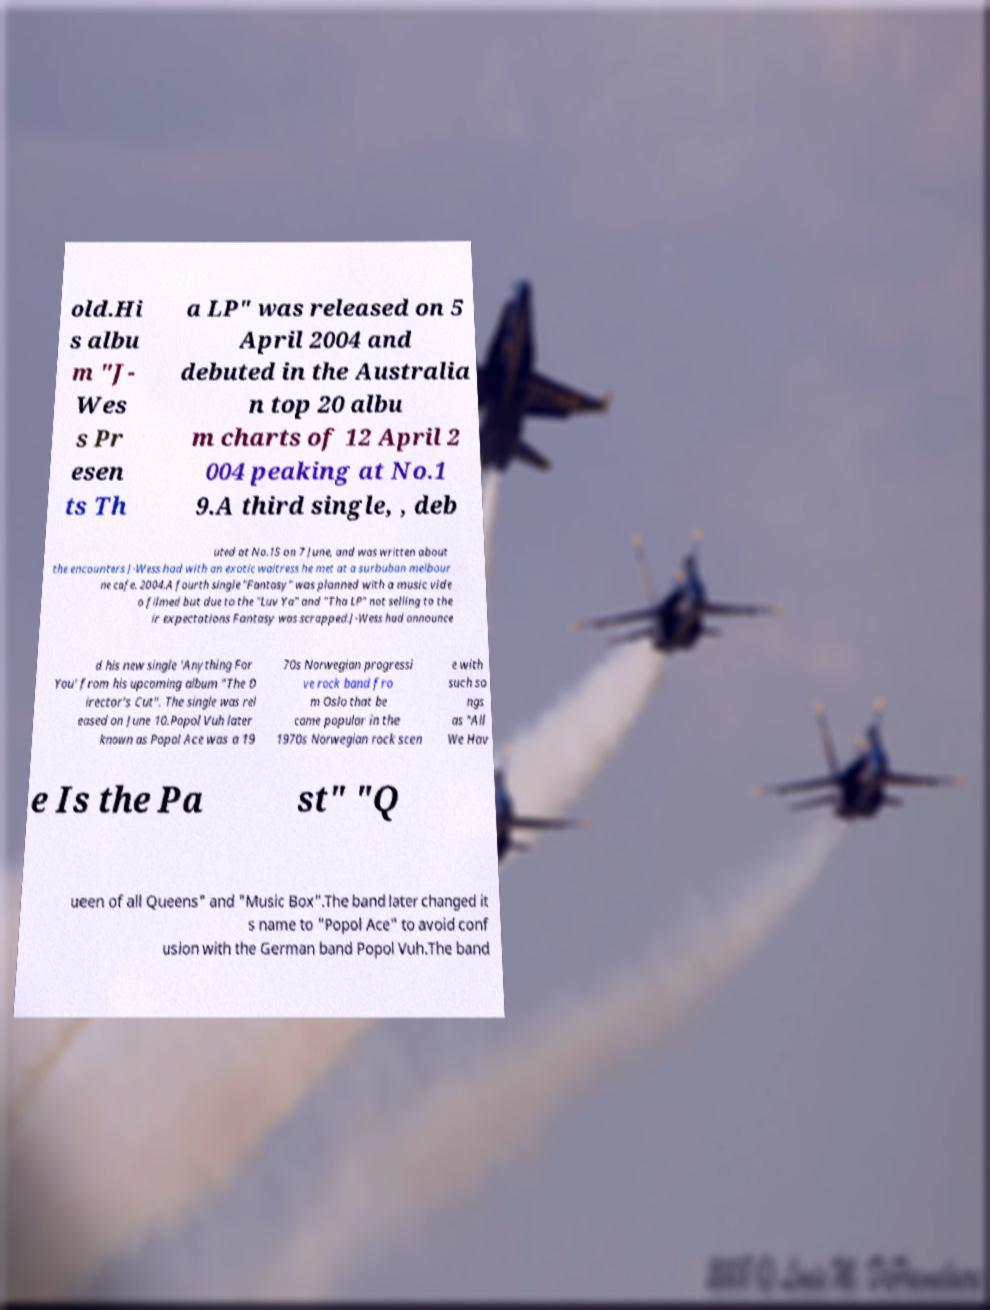Can you read and provide the text displayed in the image?This photo seems to have some interesting text. Can you extract and type it out for me? old.Hi s albu m "J- Wes s Pr esen ts Th a LP" was released on 5 April 2004 and debuted in the Australia n top 20 albu m charts of 12 April 2 004 peaking at No.1 9.A third single, , deb uted at No.15 on 7 June, and was written about the encounters J-Wess had with an exotic waitress he met at a surbuban melbour ne cafe. 2004.A fourth single "Fantasy" was planned with a music vide o filmed but due to the "Luv Ya" and "Tha LP" not selling to the ir expectations Fantasy was scrapped.J-Wess had announce d his new single 'Anything For You' from his upcoming album "The D irector's Cut". The single was rel eased on June 10.Popol Vuh later known as Popol Ace was a 19 70s Norwegian progressi ve rock band fro m Oslo that be came popular in the 1970s Norwegian rock scen e with such so ngs as "All We Hav e Is the Pa st" "Q ueen of all Queens" and "Music Box".The band later changed it s name to "Popol Ace" to avoid conf usion with the German band Popol Vuh.The band 